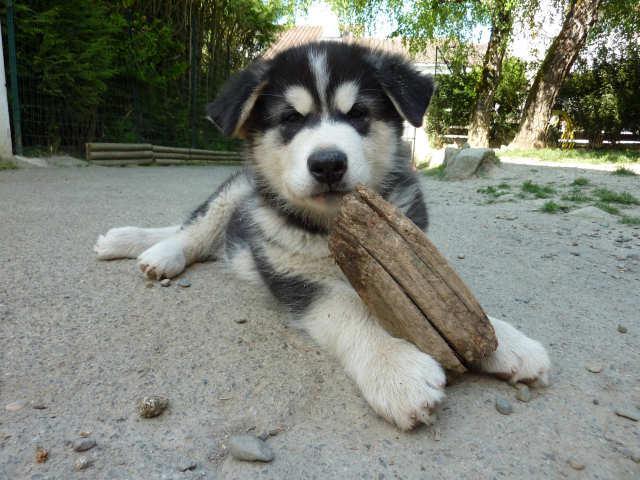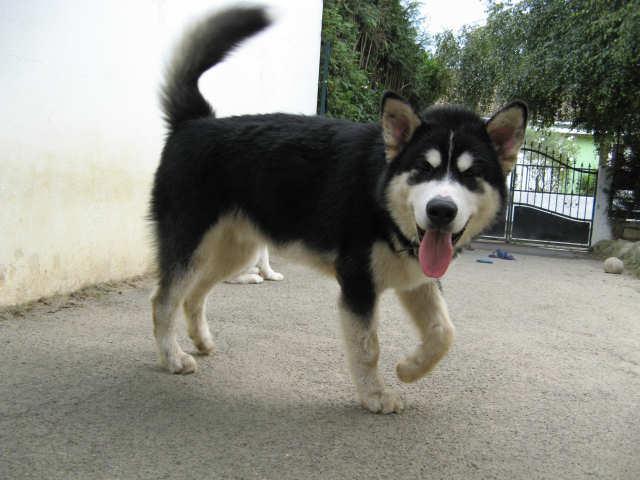The first image is the image on the left, the second image is the image on the right. For the images displayed, is the sentence "Each image contains one dog, each dog has its tongue hanging down, one dog is sitting upright, and one dog is standing." factually correct? Answer yes or no. No. The first image is the image on the left, the second image is the image on the right. Assess this claim about the two images: "Both dogs have their tongues hanging out.". Correct or not? Answer yes or no. No. 